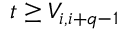Convert formula to latex. <formula><loc_0><loc_0><loc_500><loc_500>t \geq V _ { i , i + q - 1 }</formula> 